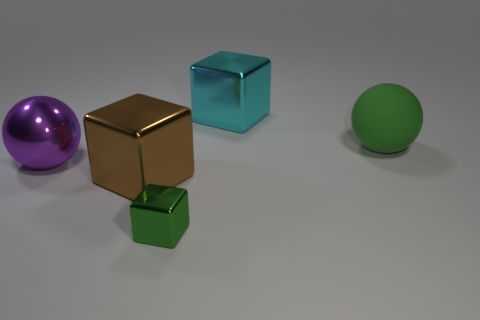What number of objects are either metallic things or tiny brown metallic blocks?
Offer a very short reply. 4. Is there anything else that is the same material as the cyan thing?
Make the answer very short. Yes. Are any tiny red cubes visible?
Give a very brief answer. No. Are the big ball that is right of the tiny block and the cyan object made of the same material?
Offer a terse response. No. Is there another tiny object of the same shape as the purple metal object?
Make the answer very short. No. Are there an equal number of green shiny objects behind the brown metal cube and big brown metal cubes?
Keep it short and to the point. No. There is a big sphere left of the big metal object that is to the right of the brown shiny block; what is it made of?
Your answer should be compact. Metal. The big green thing has what shape?
Provide a short and direct response. Sphere. Is the number of purple metallic things that are on the right side of the tiny metallic block the same as the number of big metallic things to the right of the big brown metallic block?
Your response must be concise. No. Does the matte ball that is to the right of the green metal block have the same color as the thing in front of the brown thing?
Your response must be concise. Yes. 